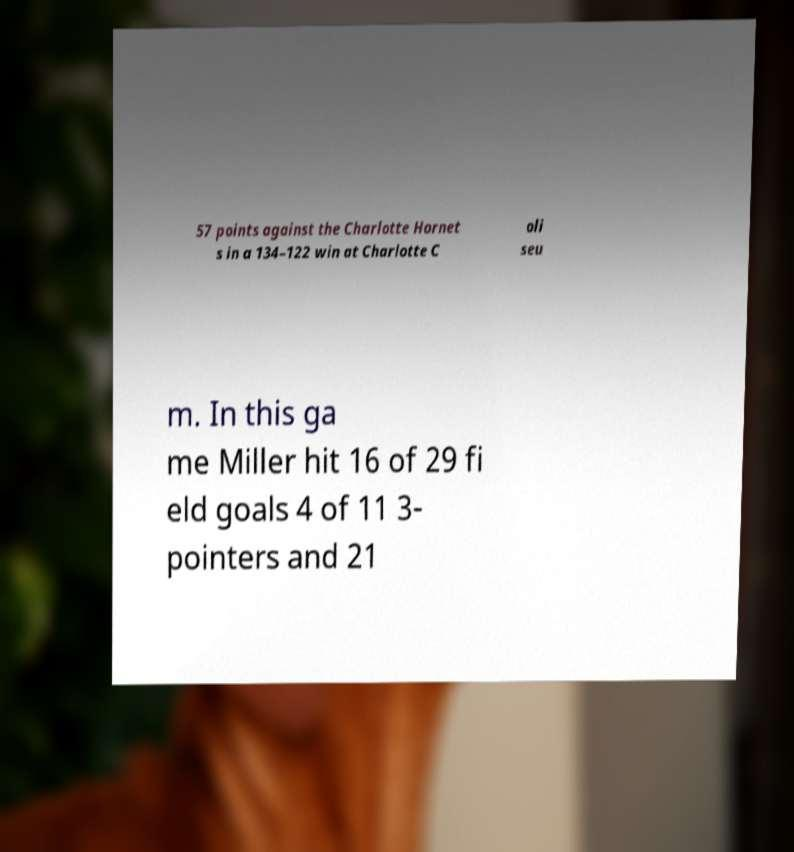Can you accurately transcribe the text from the provided image for me? 57 points against the Charlotte Hornet s in a 134–122 win at Charlotte C oli seu m. In this ga me Miller hit 16 of 29 fi eld goals 4 of 11 3- pointers and 21 